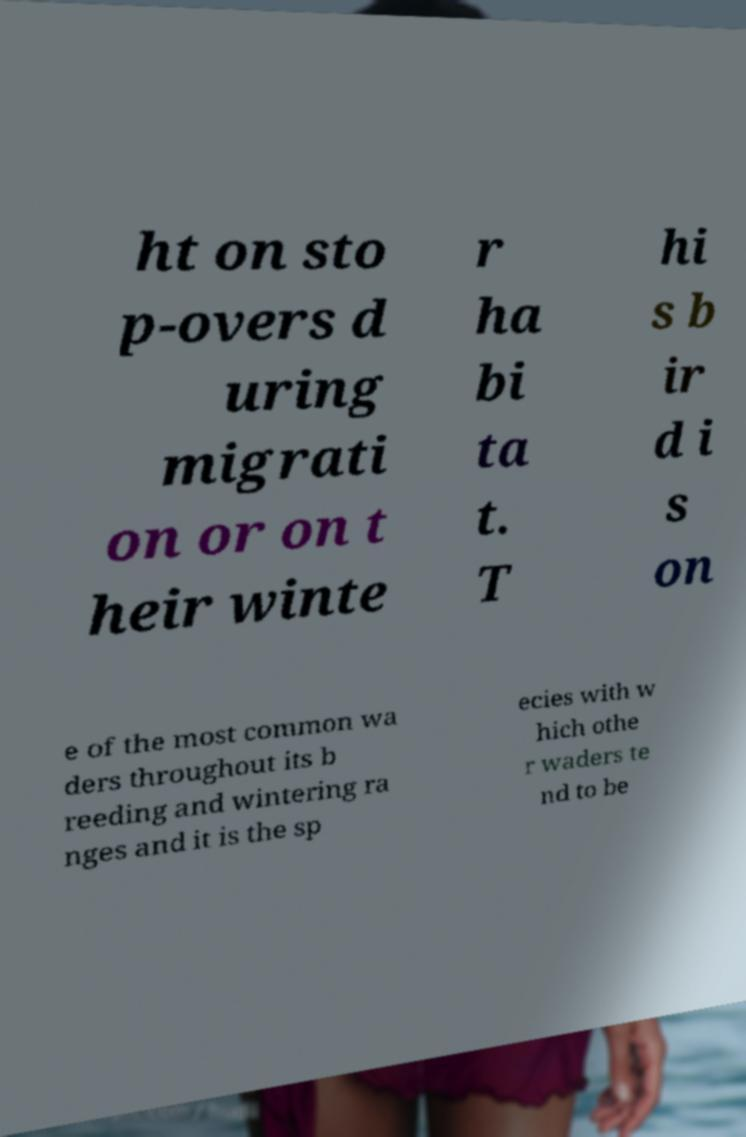Could you extract and type out the text from this image? ht on sto p-overs d uring migrati on or on t heir winte r ha bi ta t. T hi s b ir d i s on e of the most common wa ders throughout its b reeding and wintering ra nges and it is the sp ecies with w hich othe r waders te nd to be 